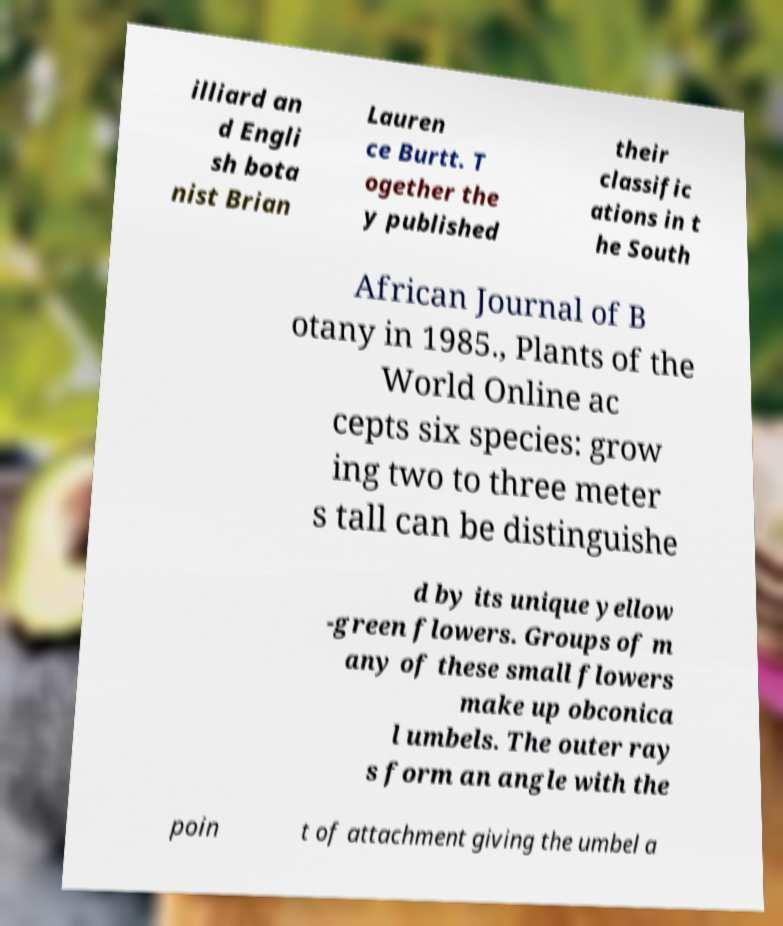I need the written content from this picture converted into text. Can you do that? illiard an d Engli sh bota nist Brian Lauren ce Burtt. T ogether the y published their classific ations in t he South African Journal of B otany in 1985., Plants of the World Online ac cepts six species: grow ing two to three meter s tall can be distinguishe d by its unique yellow -green flowers. Groups of m any of these small flowers make up obconica l umbels. The outer ray s form an angle with the poin t of attachment giving the umbel a 